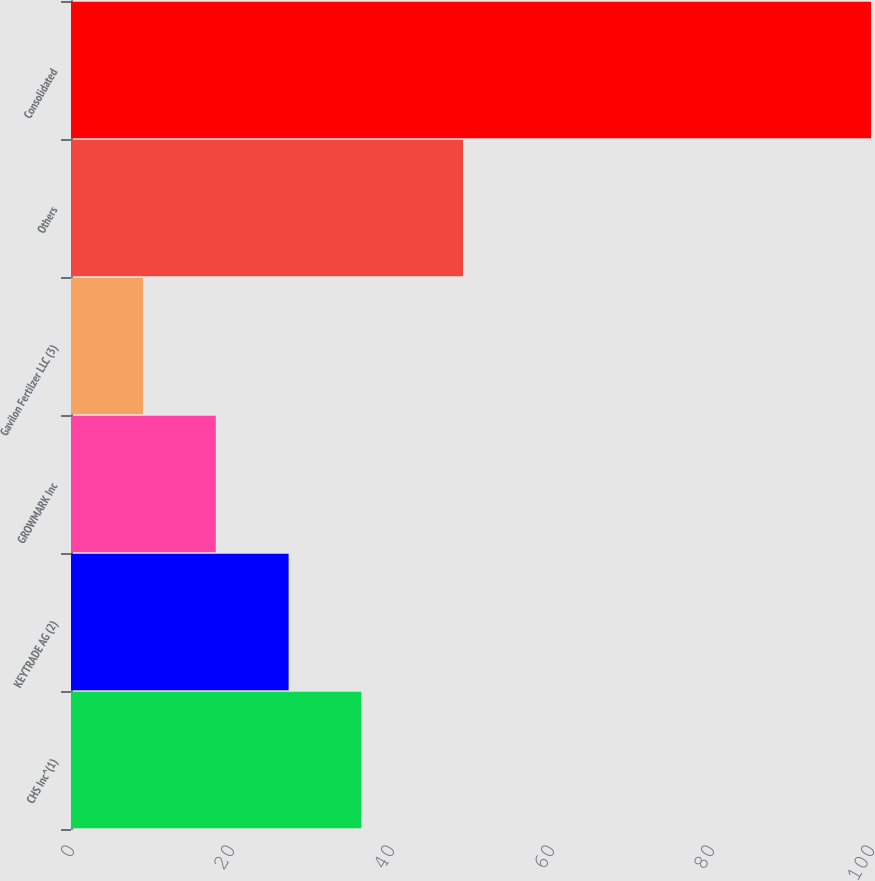Convert chart to OTSL. <chart><loc_0><loc_0><loc_500><loc_500><bar_chart><fcel>CHS Inc^(1)<fcel>KEYTRADE AG (2)<fcel>GROWMARK Inc<fcel>Gavilon Fertilzer LLC (3)<fcel>Others<fcel>Consolidated<nl><fcel>36.3<fcel>27.2<fcel>18.1<fcel>9<fcel>49<fcel>100<nl></chart> 